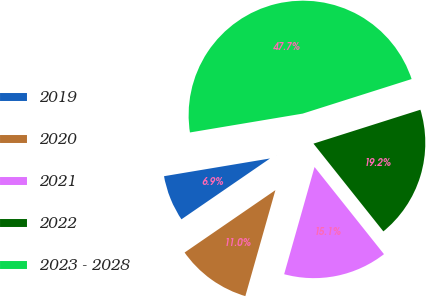<chart> <loc_0><loc_0><loc_500><loc_500><pie_chart><fcel>2019<fcel>2020<fcel>2021<fcel>2022<fcel>2023 - 2028<nl><fcel>6.94%<fcel>11.02%<fcel>15.1%<fcel>19.18%<fcel>47.74%<nl></chart> 